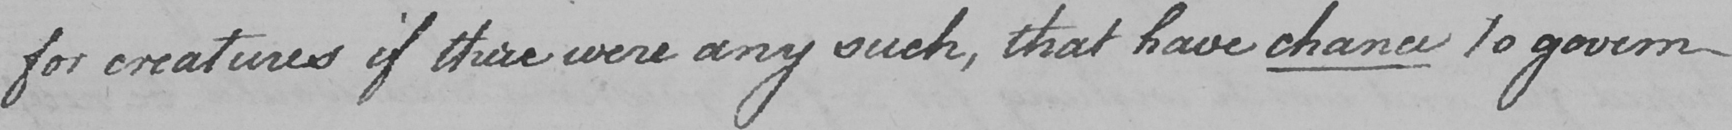What does this handwritten line say? for creatures if there were any such , that have chance to govern 